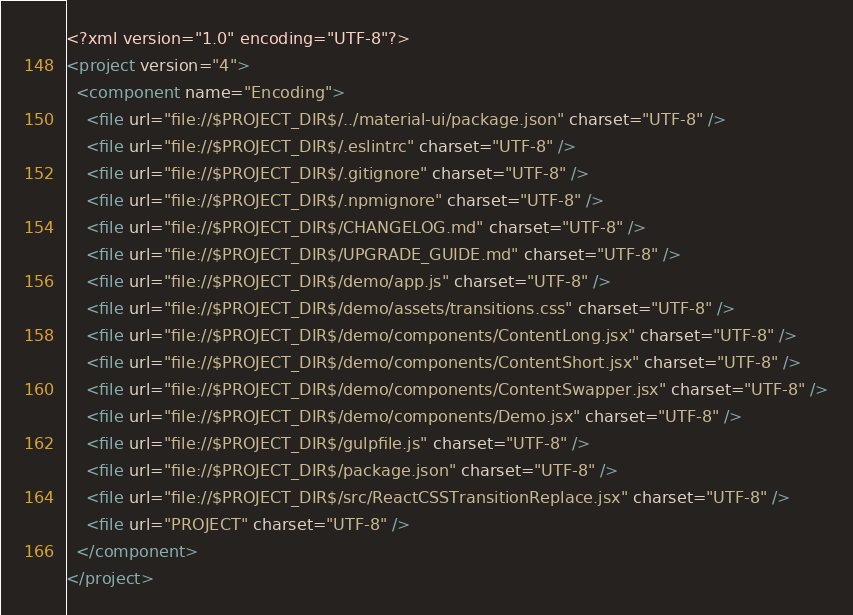Convert code to text. <code><loc_0><loc_0><loc_500><loc_500><_XML_><?xml version="1.0" encoding="UTF-8"?>
<project version="4">
  <component name="Encoding">
    <file url="file://$PROJECT_DIR$/../material-ui/package.json" charset="UTF-8" />
    <file url="file://$PROJECT_DIR$/.eslintrc" charset="UTF-8" />
    <file url="file://$PROJECT_DIR$/.gitignore" charset="UTF-8" />
    <file url="file://$PROJECT_DIR$/.npmignore" charset="UTF-8" />
    <file url="file://$PROJECT_DIR$/CHANGELOG.md" charset="UTF-8" />
    <file url="file://$PROJECT_DIR$/UPGRADE_GUIDE.md" charset="UTF-8" />
    <file url="file://$PROJECT_DIR$/demo/app.js" charset="UTF-8" />
    <file url="file://$PROJECT_DIR$/demo/assets/transitions.css" charset="UTF-8" />
    <file url="file://$PROJECT_DIR$/demo/components/ContentLong.jsx" charset="UTF-8" />
    <file url="file://$PROJECT_DIR$/demo/components/ContentShort.jsx" charset="UTF-8" />
    <file url="file://$PROJECT_DIR$/demo/components/ContentSwapper.jsx" charset="UTF-8" />
    <file url="file://$PROJECT_DIR$/demo/components/Demo.jsx" charset="UTF-8" />
    <file url="file://$PROJECT_DIR$/gulpfile.js" charset="UTF-8" />
    <file url="file://$PROJECT_DIR$/package.json" charset="UTF-8" />
    <file url="file://$PROJECT_DIR$/src/ReactCSSTransitionReplace.jsx" charset="UTF-8" />
    <file url="PROJECT" charset="UTF-8" />
  </component>
</project></code> 